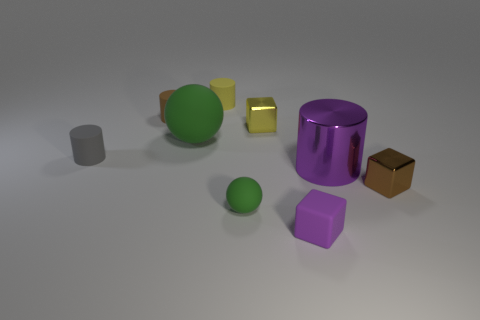Subtract all cyan spheres. Subtract all gray cylinders. How many spheres are left? 2 Subtract all cylinders. How many objects are left? 5 Subtract 0 red cubes. How many objects are left? 9 Subtract all small spheres. Subtract all small yellow things. How many objects are left? 6 Add 5 yellow shiny cubes. How many yellow shiny cubes are left? 6 Add 9 red objects. How many red objects exist? 9 